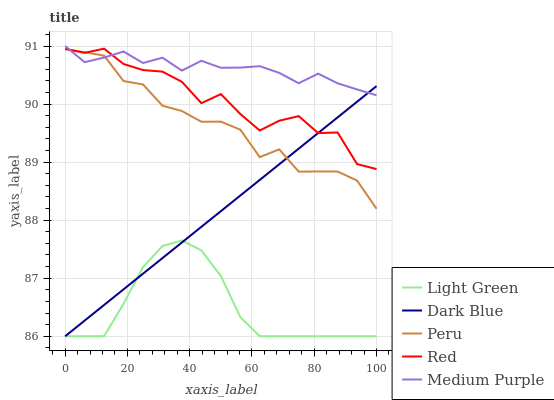Does Light Green have the minimum area under the curve?
Answer yes or no. Yes. Does Medium Purple have the maximum area under the curve?
Answer yes or no. Yes. Does Dark Blue have the minimum area under the curve?
Answer yes or no. No. Does Dark Blue have the maximum area under the curve?
Answer yes or no. No. Is Dark Blue the smoothest?
Answer yes or no. Yes. Is Red the roughest?
Answer yes or no. Yes. Is Red the smoothest?
Answer yes or no. No. Is Dark Blue the roughest?
Answer yes or no. No. Does Dark Blue have the lowest value?
Answer yes or no. Yes. Does Red have the lowest value?
Answer yes or no. No. Does Medium Purple have the highest value?
Answer yes or no. Yes. Does Dark Blue have the highest value?
Answer yes or no. No. Is Light Green less than Peru?
Answer yes or no. Yes. Is Red greater than Light Green?
Answer yes or no. Yes. Does Red intersect Peru?
Answer yes or no. Yes. Is Red less than Peru?
Answer yes or no. No. Is Red greater than Peru?
Answer yes or no. No. Does Light Green intersect Peru?
Answer yes or no. No. 